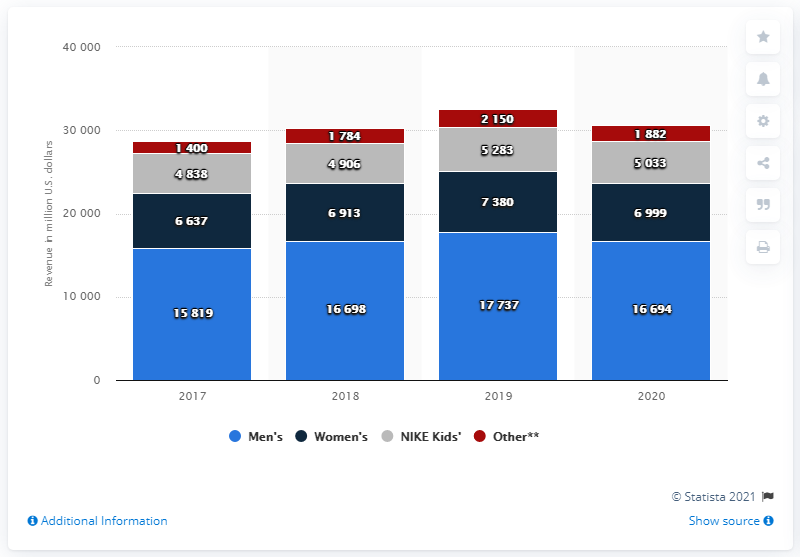Indicate a few pertinent items in this graphic. In 2020, Nike's Men's segment in the U.S. generated approximately 16,694 revenue. 